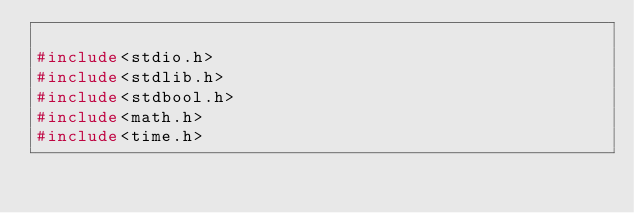Convert code to text. <code><loc_0><loc_0><loc_500><loc_500><_C_>
#include<stdio.h>
#include<stdlib.h>
#include<stdbool.h>
#include<math.h>
#include<time.h>
</code> 